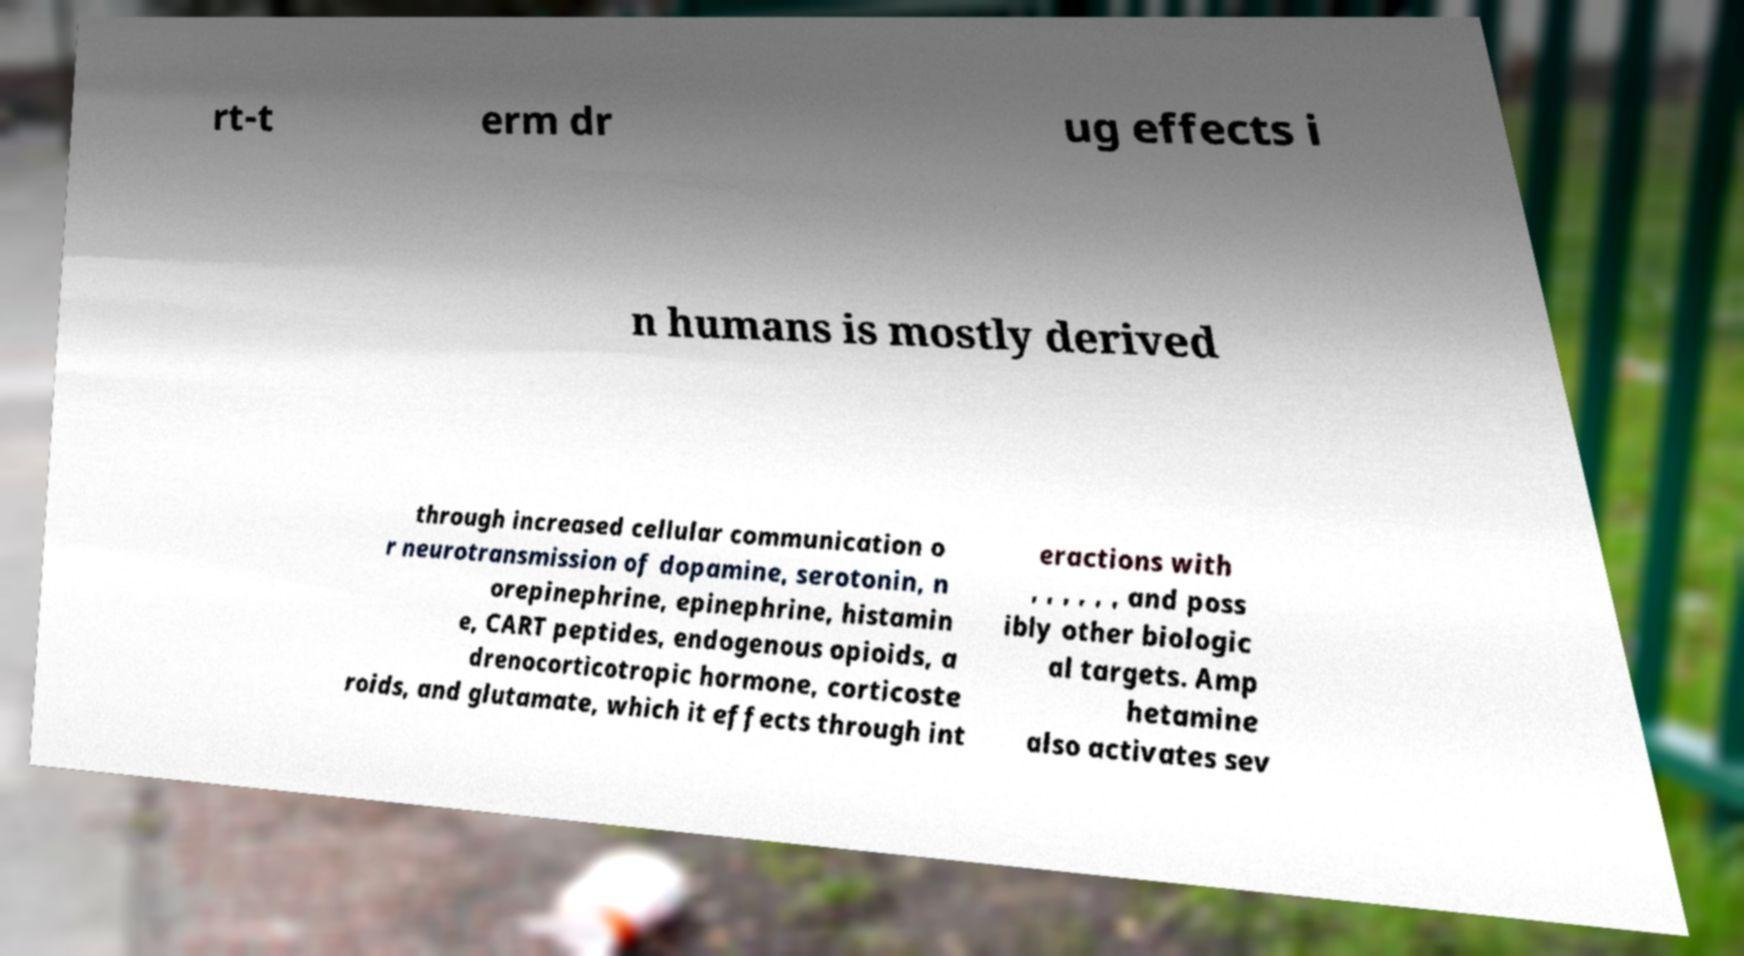There's text embedded in this image that I need extracted. Can you transcribe it verbatim? rt-t erm dr ug effects i n humans is mostly derived through increased cellular communication o r neurotransmission of dopamine, serotonin, n orepinephrine, epinephrine, histamin e, CART peptides, endogenous opioids, a drenocorticotropic hormone, corticoste roids, and glutamate, which it effects through int eractions with , , , , , , and poss ibly other biologic al targets. Amp hetamine also activates sev 